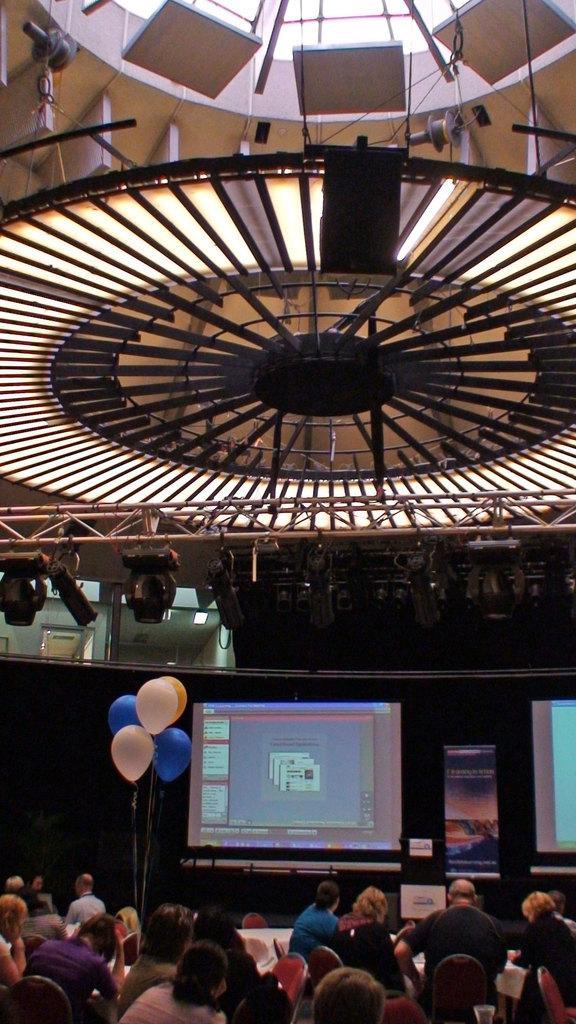Could you give a brief overview of what you see in this image? In this image there are so many people sitting on their chairs in front of the tables, there is a screen with some text, beside that there are balloons. At the top of the image there is a ceiling. 